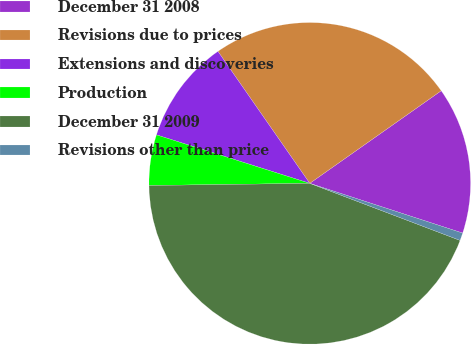Convert chart to OTSL. <chart><loc_0><loc_0><loc_500><loc_500><pie_chart><fcel>December 31 2008<fcel>Revisions due to prices<fcel>Extensions and discoveries<fcel>Production<fcel>December 31 2009<fcel>Revisions other than price<nl><fcel>14.77%<fcel>24.91%<fcel>10.45%<fcel>5.09%<fcel>44.01%<fcel>0.77%<nl></chart> 